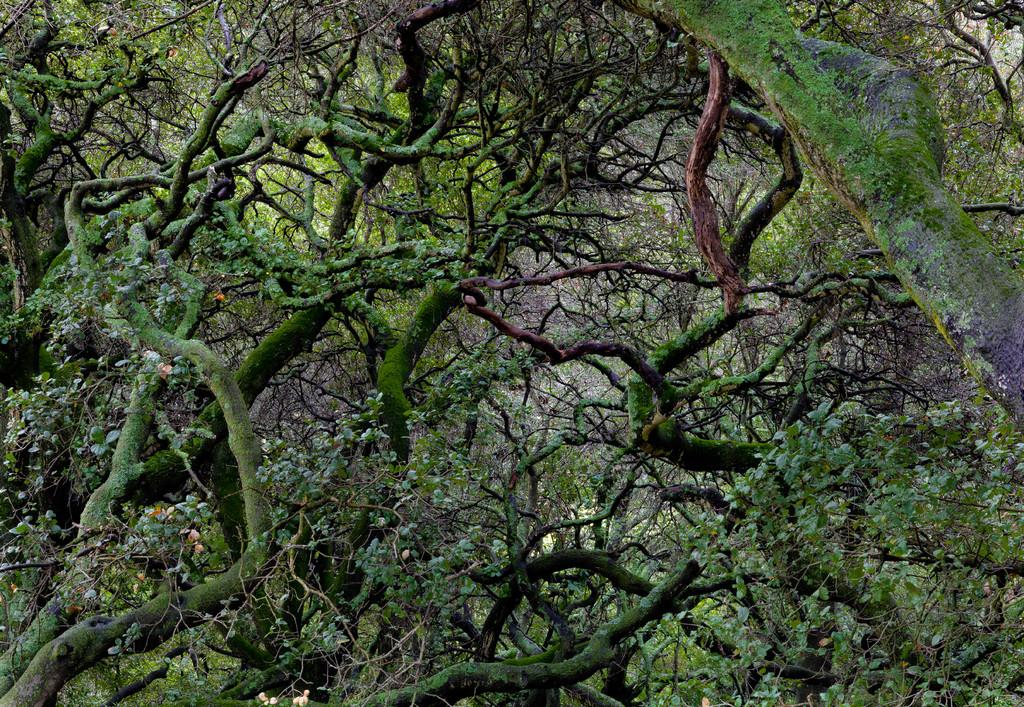What type of vegetation can be seen in the image? There are trees in the image. What part of the trees is visible in the image? The branches of the trees are visible in the image. What type of kitty can be seen playing with the branches of the trees in the image? There is no kitty present in the image, and therefore no such activity can be observed. 